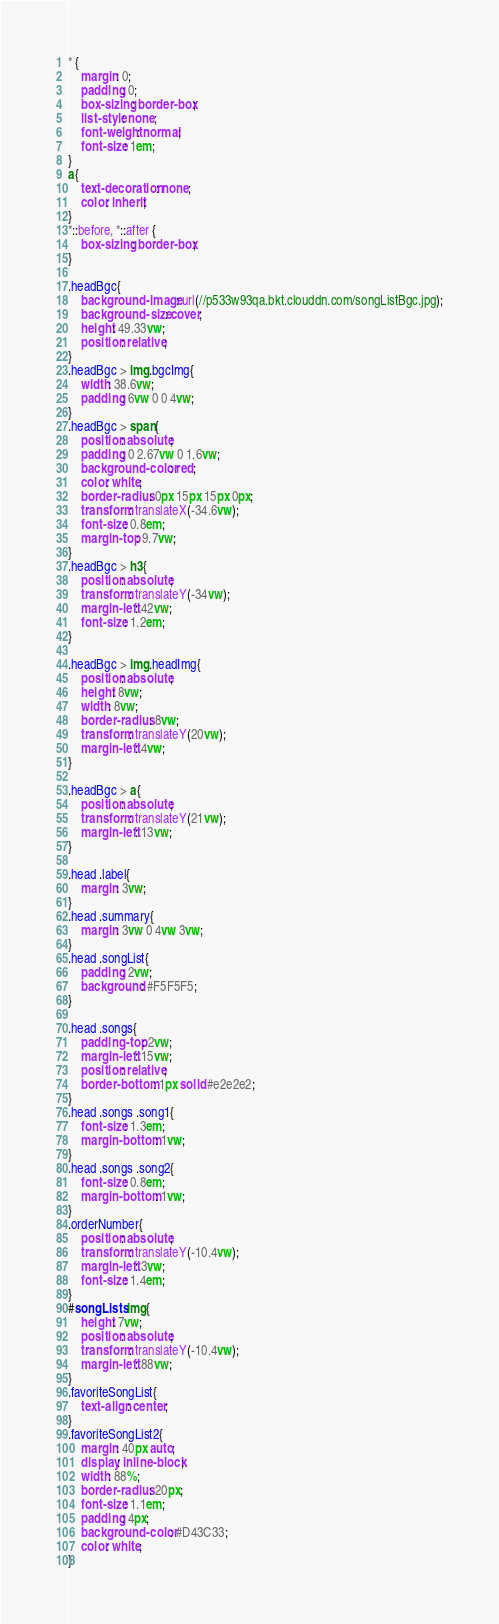<code> <loc_0><loc_0><loc_500><loc_500><_CSS_>* {
    margin: 0;
    padding: 0;
    box-sizing: border-box;
    list-style: none;
    font-weight: normal;
    font-size: 1em;
}
a{
    text-decoration: none;
    color: inherit;
}
*::before, *::after {
    box-sizing: border-box;
}

.headBgc{
    background-image: url(//p533w93qa.bkt.clouddn.com/songListBgc.jpg);
    background-size: cover;
    height: 49.33vw;
    position: relative;
}
.headBgc > img.bgcImg{
    width: 38.6vw;
    padding: 6vw 0 0 4vw;
}
.headBgc > span{
    position: absolute;
    padding: 0 2.67vw 0 1.6vw;
    background-color: red;
    color: white;
    border-radius: 0px 15px 15px 0px;
    transform: translateX(-34.6vw);
    font-size: 0.8em;
    margin-top: 9.7vw;
}
.headBgc > h3{
    position: absolute;
    transform: translateY(-34vw);
    margin-left: 42vw;
    font-size: 1.2em;
}

.headBgc > img.headImg{
    position: absolute;
    height: 8vw;
    width: 8vw;
    border-radius: 8vw;
    transform: translateY(20vw);
    margin-left: 4vw;
}

.headBgc > a{
    position: absolute;
    transform: translateY(21vw);
    margin-left: 13vw;
}

.head .label{
    margin: 3vw;
}
.head .summary{
    margin: 3vw 0 4vw 3vw;
}
.head .songList{
    padding: 2vw;
    background: #F5F5F5;
}

.head .songs{
    padding-top: 2vw;
    margin-left: 15vw;
    position: relative;
    border-bottom: 1px solid #e2e2e2;
}
.head .songs .song1{
    font-size: 1.3em;
    margin-bottom: 1vw;
}
.head .songs .song2{
    font-size: 0.8em;
    margin-bottom: 1vw;
}
.orderNumber{
    position: absolute;
    transform: translateY(-10.4vw);
    margin-left: 3vw;
    font-size: 1.4em;
}
#songLists img{
    height: 7vw;
    position: absolute;
    transform: translateY(-10.4vw);
    margin-left: 88vw;
}
.favoriteSongList{
    text-align: center;
}
.favoriteSongList2{
    margin: 40px auto;
    display: inline-block;
    width: 88%;
    border-radius: 20px;
    font-size: 1.1em;
    padding: 4px;
    background-color: #D43C33;
    color: white;
}
</code> 